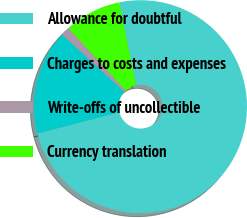<chart> <loc_0><loc_0><loc_500><loc_500><pie_chart><fcel>Allowance for doubtful<fcel>Charges to costs and expenses<fcel>Write-offs of uncollectible<fcel>Currency translation<nl><fcel>74.15%<fcel>15.9%<fcel>1.34%<fcel>8.62%<nl></chart> 